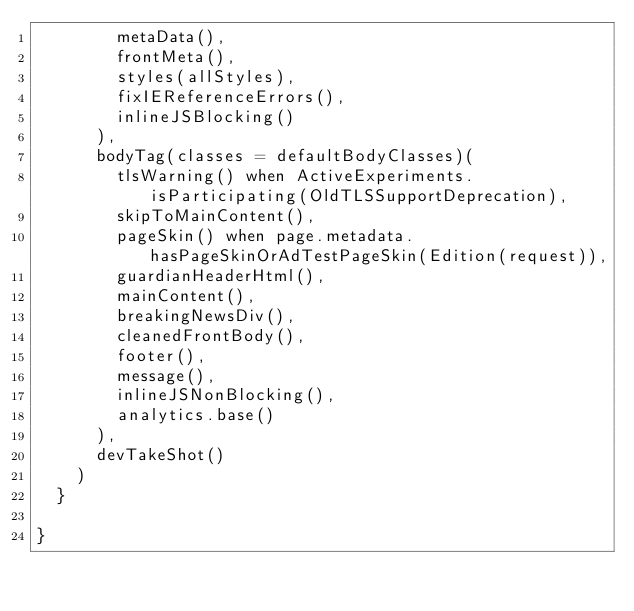<code> <loc_0><loc_0><loc_500><loc_500><_Scala_>        metaData(),
        frontMeta(),
        styles(allStyles),
        fixIEReferenceErrors(),
        inlineJSBlocking()
      ),
      bodyTag(classes = defaultBodyClasses)(
        tlsWarning() when ActiveExperiments.isParticipating(OldTLSSupportDeprecation),
        skipToMainContent(),
        pageSkin() when page.metadata.hasPageSkinOrAdTestPageSkin(Edition(request)),
        guardianHeaderHtml(),
        mainContent(),
        breakingNewsDiv(),
        cleanedFrontBody(),
        footer(),
        message(),
        inlineJSNonBlocking(),
        analytics.base()
      ),
      devTakeShot()
    )
  }

}
</code> 